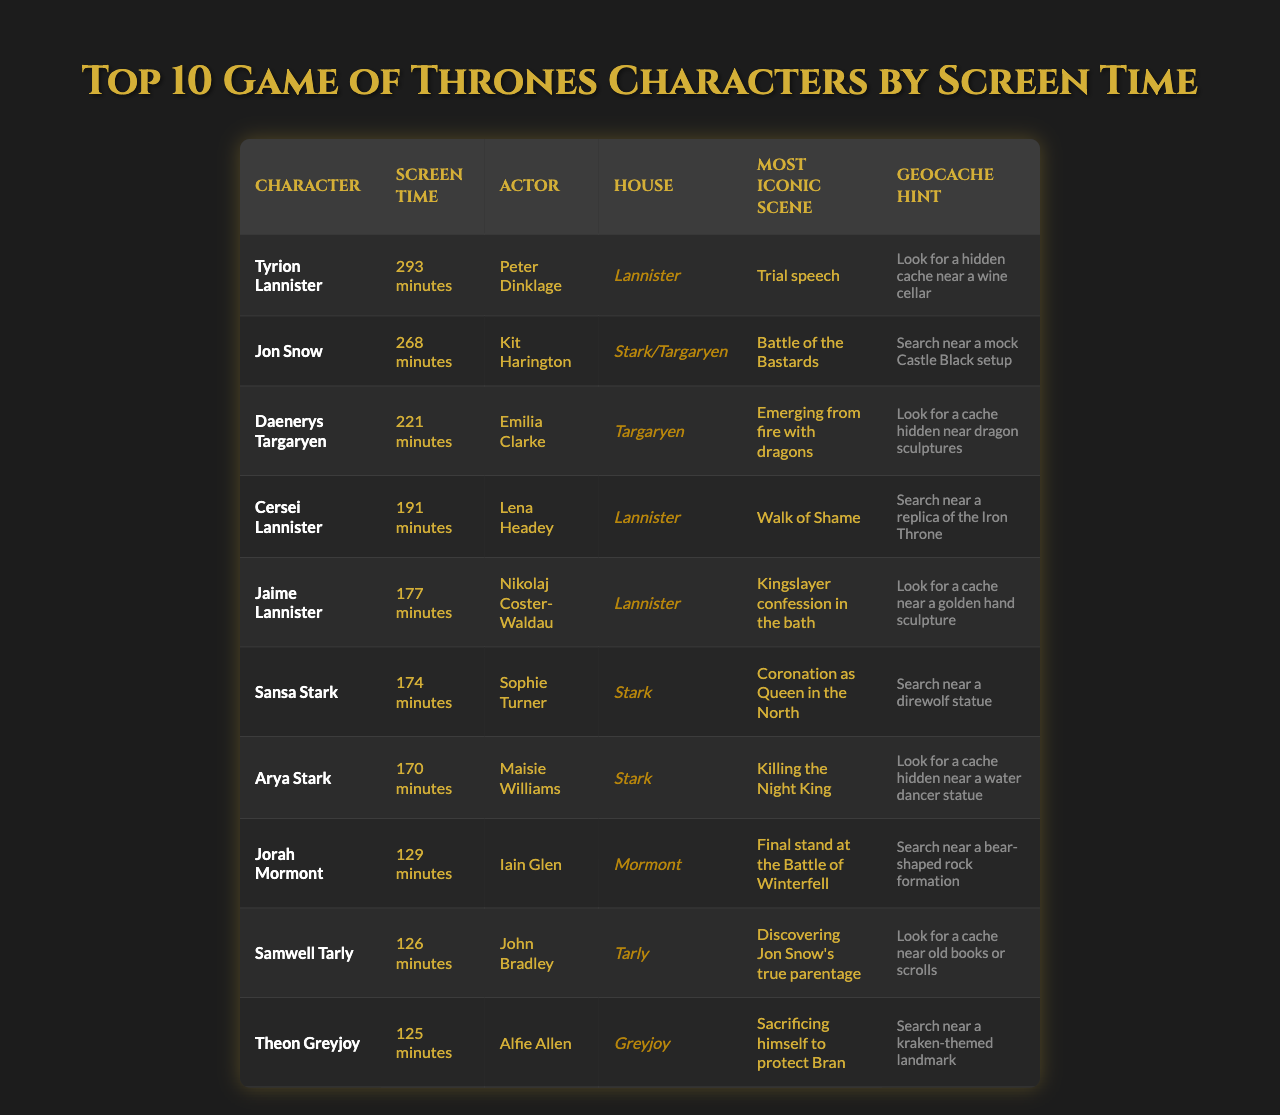What is the character with the longest screen time? The character with the longest screen time listed in the table is Tyrion Lannister, who has 293 minutes of screen time.
Answer: Tyrion Lannister Which two characters have the same last appearance? Both Jon Snow and Daenerys Targaryen last appeared in Season 8, Episode 6, as noted in the 'Last Appearance' column.
Answer: Jon Snow and Daenerys Targaryen How many more minutes of screen time does Tyrion Lannister have than Jaime Lannister? Tyrion has 293 minutes and Jaime has 177 minutes. The difference is 293 - 177 = 116 minutes.
Answer: 116 minutes What is the house affiliation of the character with the most iconic scene involving a trial speech? The character with the most iconic scene involving a trial speech is Tyrion Lannister; his house affiliation is Lannister.
Answer: Lannister Is there a character who has screen time less than 130 minutes? Yes, Jorah Mormont (129 minutes), Samwell Tarly (126 minutes), and Theon Greyjoy (125 minutes) all have screen time less than 130 minutes.
Answer: Yes Who are the characters affiliated with House Stark? The characters affiliated with House Stark are Jon Snow, Sansa Stark, and Arya Stark, as indicated in the 'House Affiliation' column.
Answer: Jon Snow, Sansa Stark, Arya Stark If we took the average screen time of the top three characters, what would it be? The screen times for the top three characters are 293, 268, and 221 minutes. Their total is 293 + 268 + 221 = 782 minutes. The average is 782 / 3 = approximately 260.67 minutes.
Answer: Approximately 260.67 minutes How many characters have screen time over 200 minutes? The only character with screen time over 200 minutes is Tyrion Lannister (293 minutes), Jon Snow (268 minutes), and Daenerys Targaryen (221 minutes), totaling three characters.
Answer: Three characters Which character's most iconic scene includes a final stand at the Battle of Winterfell? Jorah Mormont's most iconic scene is about his final stand at the Battle of Winterfell.
Answer: Jorah Mormont Is Cersei Lannister affiliated with House Stark? No, Cersei Lannister is affiliated with House Lannister, not House Stark.
Answer: No 